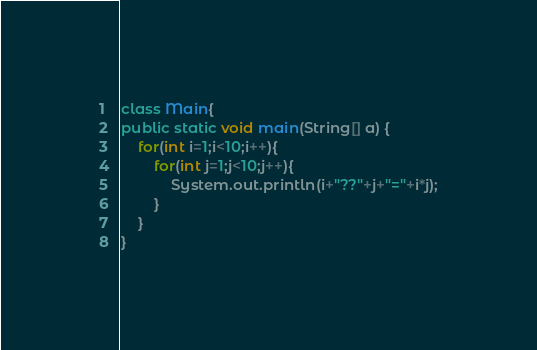Convert code to text. <code><loc_0><loc_0><loc_500><loc_500><_Java_>class Main{
public static void main(String[] a) {
	for(int i=1;i<10;i++){
		for(int j=1;j<10;j++){
			System.out.println(i+"??"+j+"="+i*j);
		}
	}
}</code> 